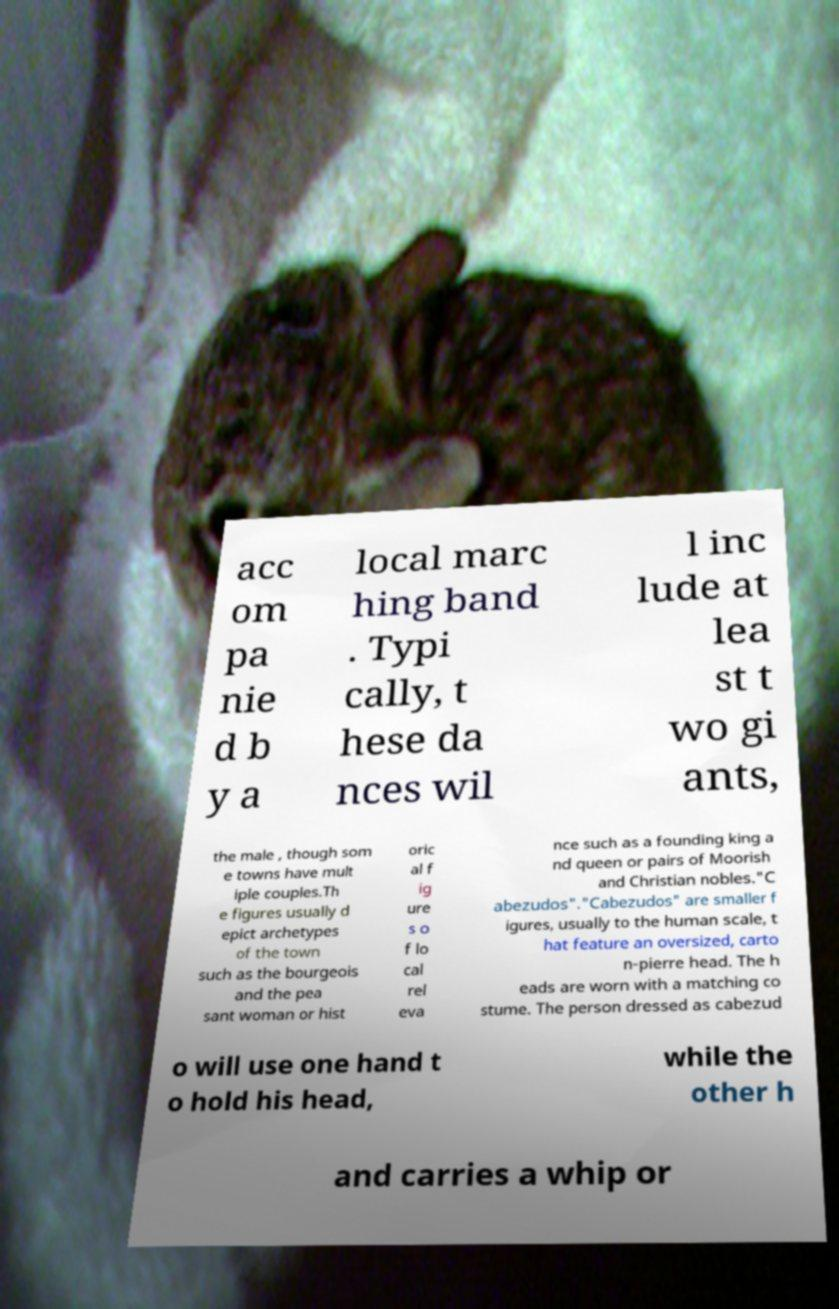Please read and relay the text visible in this image. What does it say? acc om pa nie d b y a local marc hing band . Typi cally, t hese da nces wil l inc lude at lea st t wo gi ants, the male , though som e towns have mult iple couples.Th e figures usually d epict archetypes of the town such as the bourgeois and the pea sant woman or hist oric al f ig ure s o f lo cal rel eva nce such as a founding king a nd queen or pairs of Moorish and Christian nobles."C abezudos"."Cabezudos" are smaller f igures, usually to the human scale, t hat feature an oversized, carto n-pierre head. The h eads are worn with a matching co stume. The person dressed as cabezud o will use one hand t o hold his head, while the other h and carries a whip or 